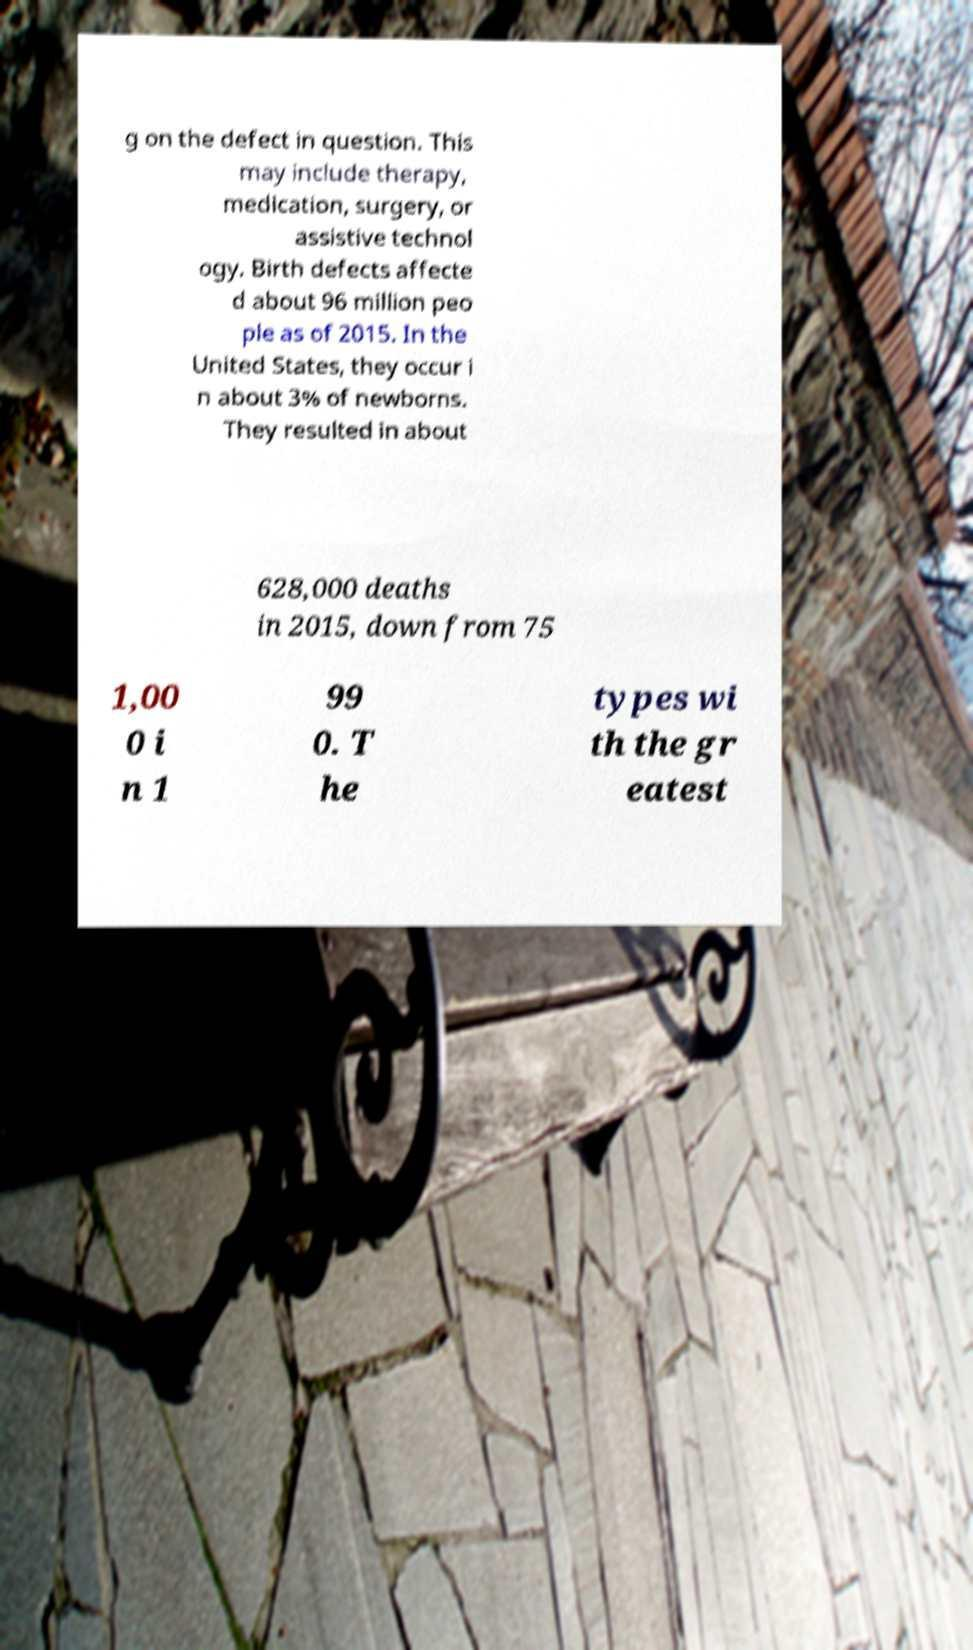Please read and relay the text visible in this image. What does it say? g on the defect in question. This may include therapy, medication, surgery, or assistive technol ogy. Birth defects affecte d about 96 million peo ple as of 2015. In the United States, they occur i n about 3% of newborns. They resulted in about 628,000 deaths in 2015, down from 75 1,00 0 i n 1 99 0. T he types wi th the gr eatest 